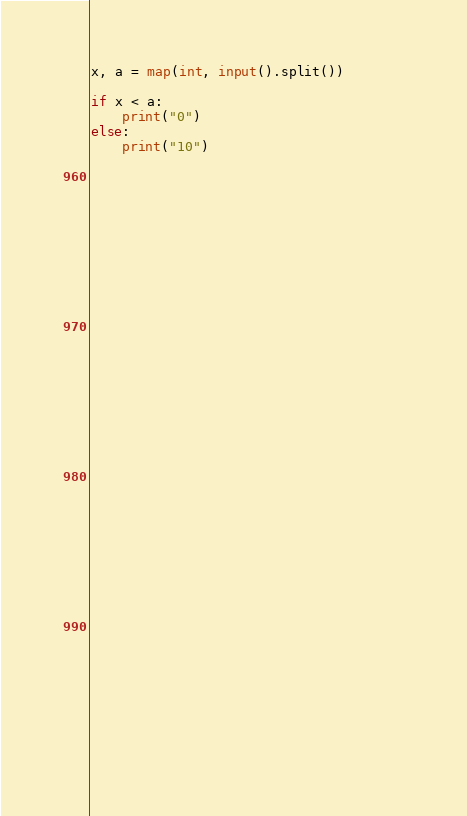Convert code to text. <code><loc_0><loc_0><loc_500><loc_500><_Python_>x, a = map(int, input().split())

if x < a:
    print("0")
else:
    print("10")


    
        
            



    









                                        




    




        


    







        

</code> 